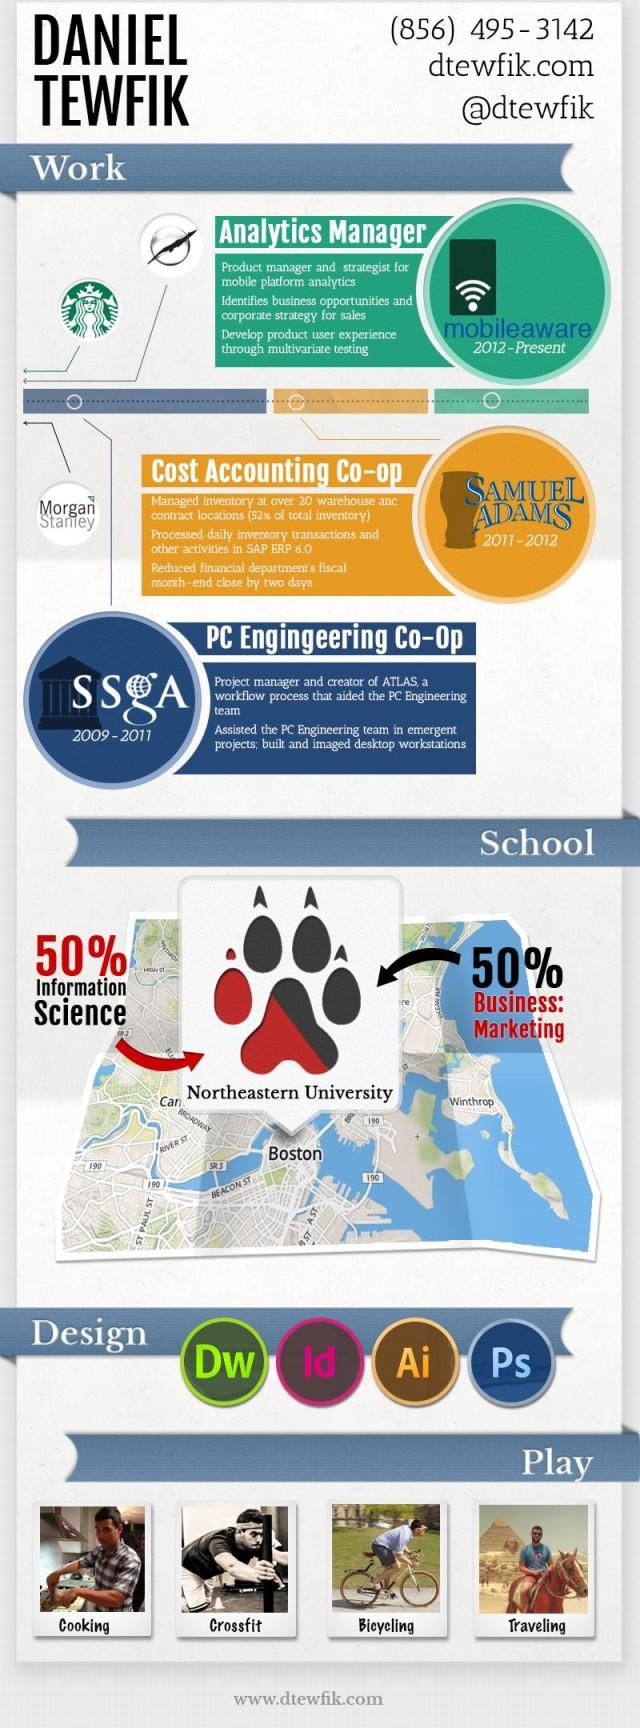Indicate a few pertinent items in this graphic. Northeastern University is located in Boston, as indicated by the map. Daniel Tewfik managed inventory at SAMUEL ADAMS. 